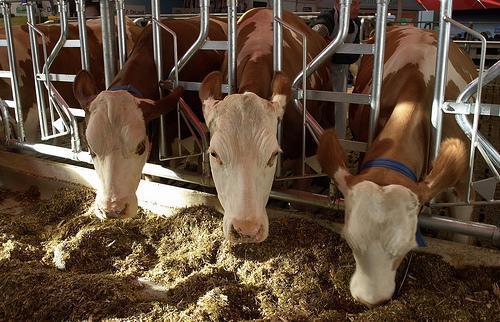How many cows are in the picture?
Give a very brief answer. 3. 